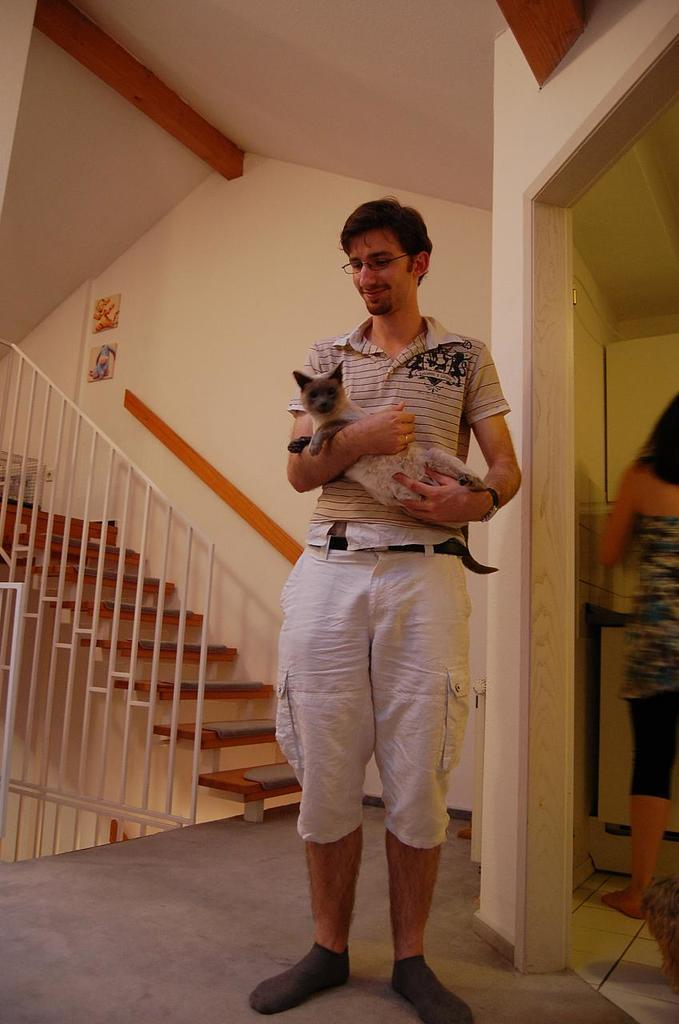What is the main subject of the image? There is a man in the image. What is the man doing in the image? The man is standing and holding a cat in his hands. Can you describe the woman in the image? There is a woman on the right side of the image. What architectural feature can be seen on the left side of the image? There is a staircase on the left side of the image. How many apples are on the man's head in the image? There are no apples present on the man's head in the image. Can you describe the man's sneeze in the image? There is no sneeze depicted in the image; the man is holding a cat in his hands. 